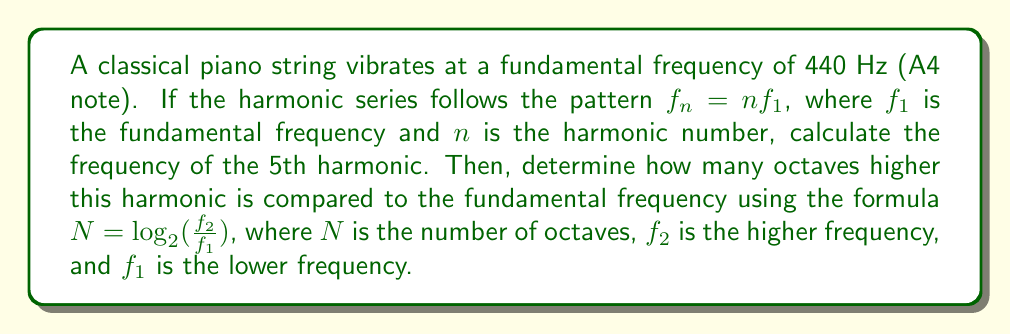Can you answer this question? 1) First, let's calculate the frequency of the 5th harmonic:
   $f_5 = 5f_1 = 5 \times 440 \text{ Hz} = 2200 \text{ Hz}$

2) Now, we need to determine how many octaves higher this is compared to the fundamental:
   We use the formula $N = \log_2(\frac{f_2}{f_1})$

3) Substituting our values:
   $N = \log_2(\frac{2200}{440})$

4) Simplify inside the logarithm:
   $N = \log_2(5)$

5) Calculate:
   $N \approx 2.32$ octaves

Therefore, the 5th harmonic (2200 Hz) is approximately 2.32 octaves higher than the fundamental frequency (440 Hz).
Answer: $2200 \text{ Hz}; 2.32 \text{ octaves}$ 